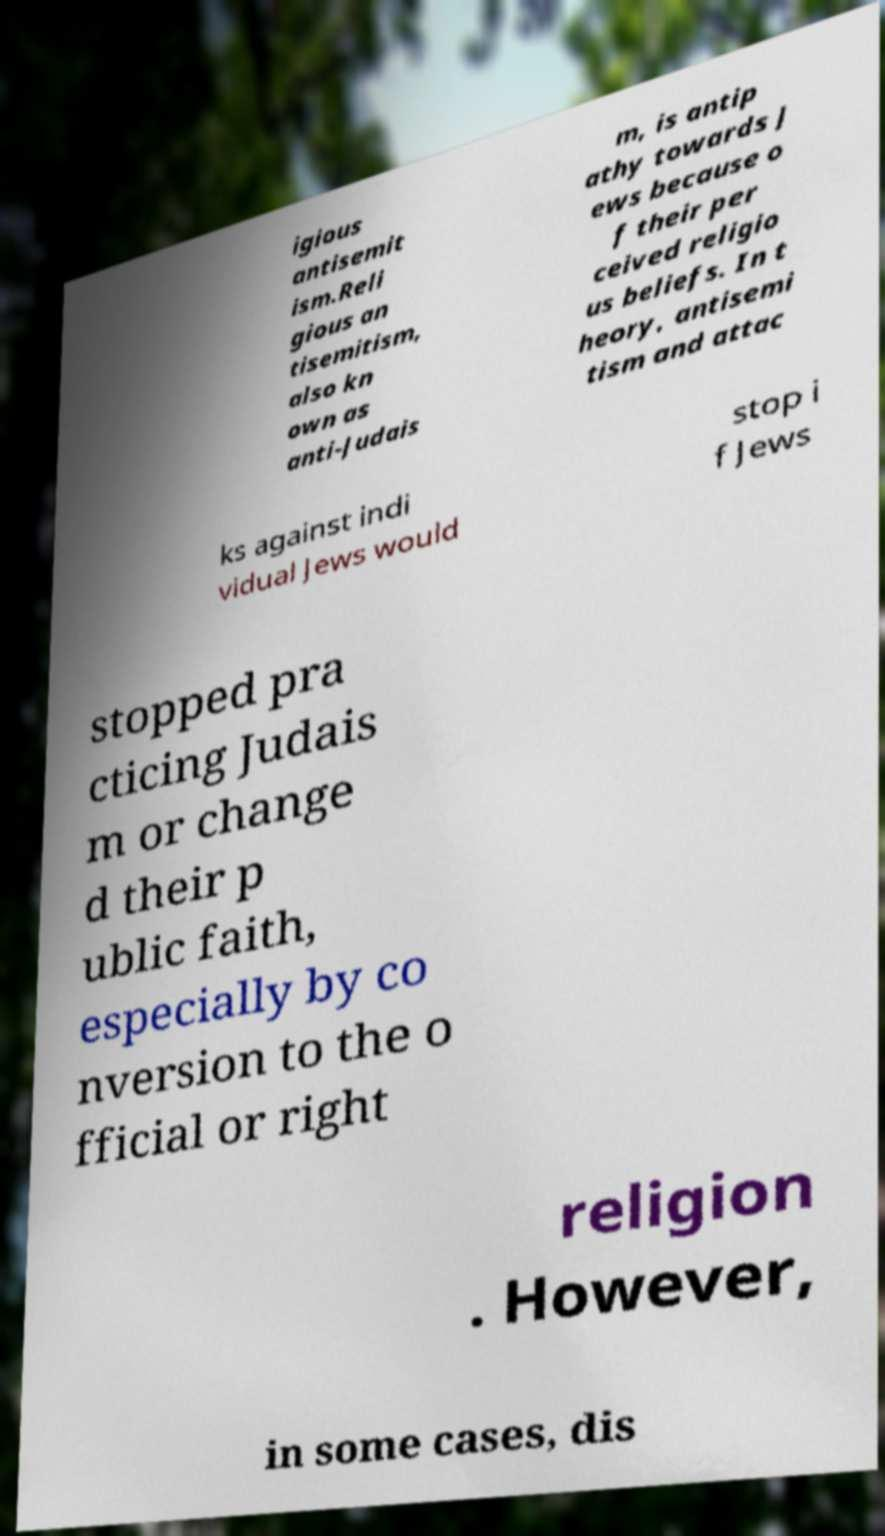Could you extract and type out the text from this image? igious antisemit ism.Reli gious an tisemitism, also kn own as anti-Judais m, is antip athy towards J ews because o f their per ceived religio us beliefs. In t heory, antisemi tism and attac ks against indi vidual Jews would stop i f Jews stopped pra cticing Judais m or change d their p ublic faith, especially by co nversion to the o fficial or right religion . However, in some cases, dis 